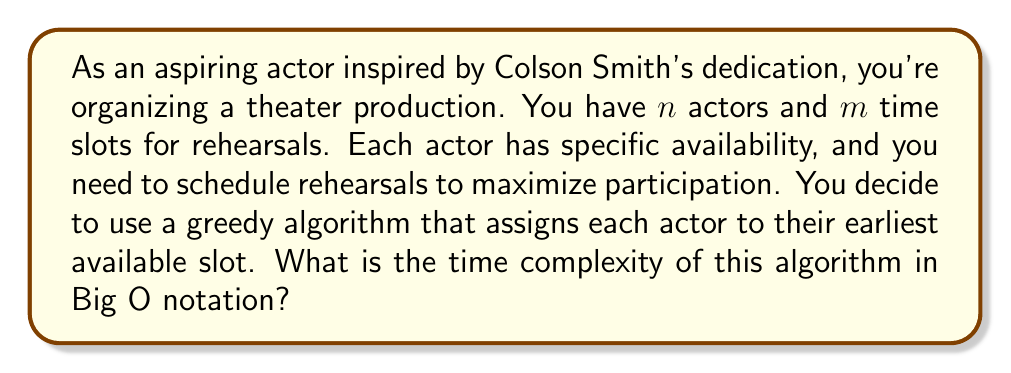Help me with this question. Let's analyze the algorithm step-by-step:

1) First, we need to sort the availability times for each actor. Assuming we use an efficient sorting algorithm like Merge Sort or Quick Sort, this step takes $O(n \log n)$ time for each actor.

2) Since we have $n$ actors, the total time for sorting all actors' availabilities is $O(n^2 \log n)$.

3) After sorting, we iterate through each actor and assign them to their earliest available slot. This involves checking each time slot for each actor in the worst case.

4) The slot assignment process takes $O(nm)$ time, as we might need to check all $m$ slots for each of the $n$ actors in the worst case.

5) Combining the sorting and assignment steps, we get:

   $O(n^2 \log n + nm)$

6) To simplify this, we need to consider the relationship between $n$ and $m$. In a typical theater production scenario, the number of time slots ($m$) is usually less than or equal to the number of actors ($n$). So, we can assume $m \leq n$.

7) Under this assumption, $nm \leq n^2$, which is dominated by $n^2 \log n$.

Therefore, the overall time complexity of the algorithm is $O(n^2 \log n)$.
Answer: $O(n^2 \log n)$ 